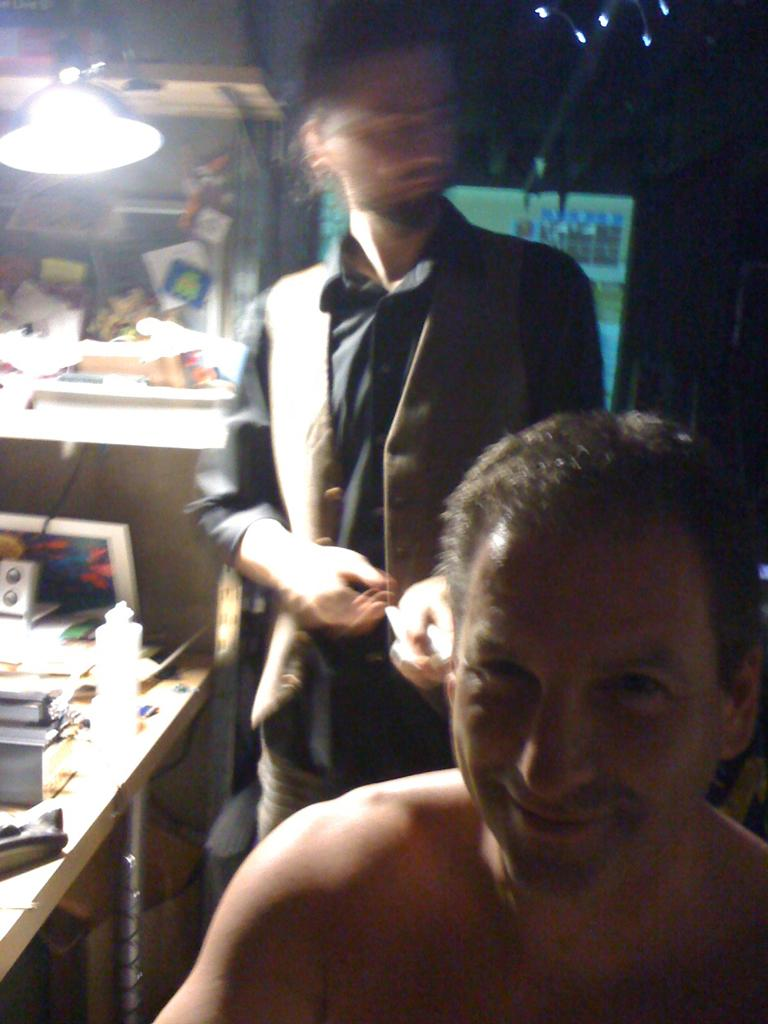How many people are in the image? There are two persons in the image. What is the primary object in the image? There is a table in the image. What can be found on the table? There are objects on the table, including papers. What type of lighting is present in the image? There is a lamp in the image. What type of knot is being tied by one of the persons in the image? There is no knot-tying activity depicted in the image. 